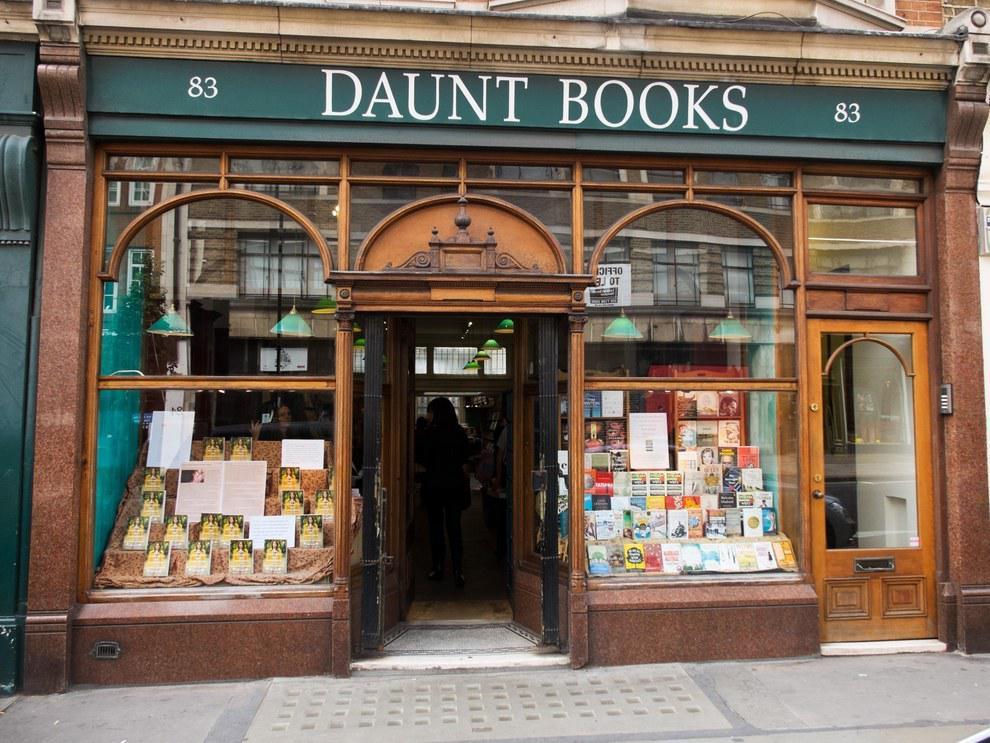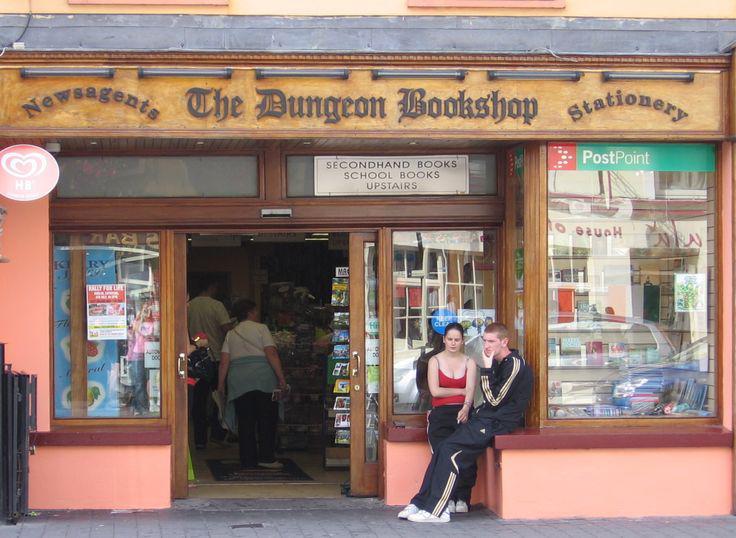The first image is the image on the left, the second image is the image on the right. Considering the images on both sides, is "A bookstore exterior has the store name on an awning over a double door and has a display stand of books outside the doors." valid? Answer yes or no. No. The first image is the image on the left, the second image is the image on the right. For the images displayed, is the sentence "The bookstore sign has white lettering on a green background." factually correct? Answer yes or no. Yes. 